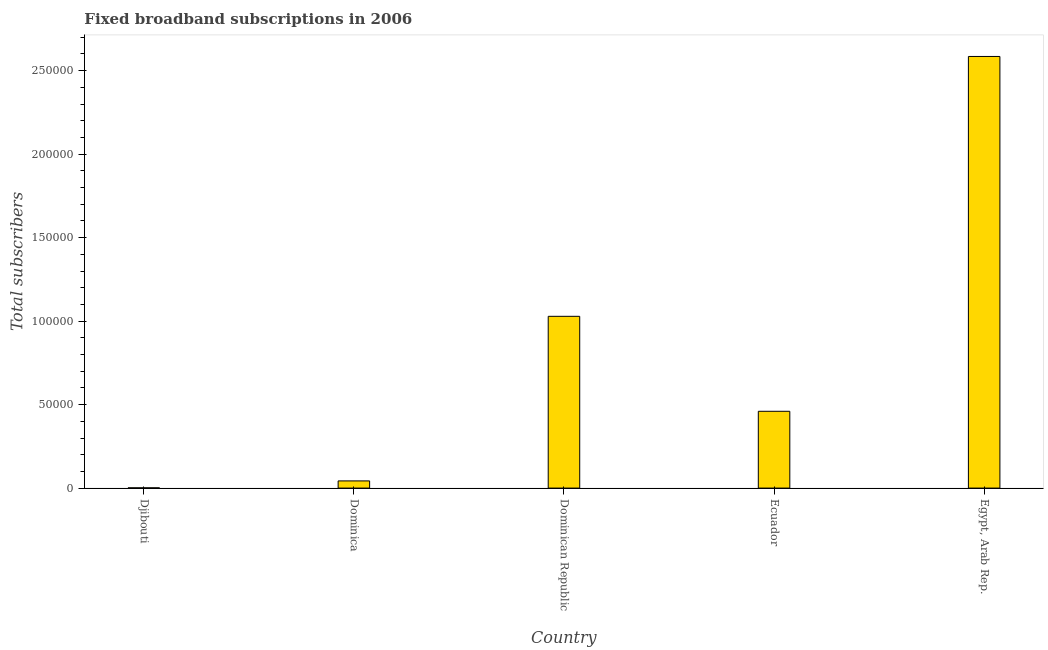What is the title of the graph?
Your answer should be very brief. Fixed broadband subscriptions in 2006. What is the label or title of the X-axis?
Give a very brief answer. Country. What is the label or title of the Y-axis?
Offer a terse response. Total subscribers. What is the total number of fixed broadband subscriptions in Ecuador?
Provide a succinct answer. 4.60e+04. Across all countries, what is the maximum total number of fixed broadband subscriptions?
Your answer should be compact. 2.59e+05. Across all countries, what is the minimum total number of fixed broadband subscriptions?
Ensure brevity in your answer.  152. In which country was the total number of fixed broadband subscriptions maximum?
Give a very brief answer. Egypt, Arab Rep. In which country was the total number of fixed broadband subscriptions minimum?
Make the answer very short. Djibouti. What is the sum of the total number of fixed broadband subscriptions?
Keep it short and to the point. 4.12e+05. What is the difference between the total number of fixed broadband subscriptions in Djibouti and Dominica?
Your response must be concise. -4148. What is the average total number of fixed broadband subscriptions per country?
Your answer should be compact. 8.24e+04. What is the median total number of fixed broadband subscriptions?
Provide a short and direct response. 4.60e+04. In how many countries, is the total number of fixed broadband subscriptions greater than 70000 ?
Keep it short and to the point. 2. What is the ratio of the total number of fixed broadband subscriptions in Dominican Republic to that in Egypt, Arab Rep.?
Keep it short and to the point. 0.4. Is the difference between the total number of fixed broadband subscriptions in Djibouti and Ecuador greater than the difference between any two countries?
Offer a very short reply. No. What is the difference between the highest and the second highest total number of fixed broadband subscriptions?
Keep it short and to the point. 1.56e+05. Is the sum of the total number of fixed broadband subscriptions in Dominican Republic and Egypt, Arab Rep. greater than the maximum total number of fixed broadband subscriptions across all countries?
Provide a succinct answer. Yes. What is the difference between the highest and the lowest total number of fixed broadband subscriptions?
Keep it short and to the point. 2.58e+05. In how many countries, is the total number of fixed broadband subscriptions greater than the average total number of fixed broadband subscriptions taken over all countries?
Your answer should be very brief. 2. How many bars are there?
Your answer should be very brief. 5. How many countries are there in the graph?
Give a very brief answer. 5. What is the Total subscribers of Djibouti?
Provide a short and direct response. 152. What is the Total subscribers in Dominica?
Your response must be concise. 4300. What is the Total subscribers in Dominican Republic?
Keep it short and to the point. 1.03e+05. What is the Total subscribers in Ecuador?
Keep it short and to the point. 4.60e+04. What is the Total subscribers in Egypt, Arab Rep.?
Provide a succinct answer. 2.59e+05. What is the difference between the Total subscribers in Djibouti and Dominica?
Your answer should be very brief. -4148. What is the difference between the Total subscribers in Djibouti and Dominican Republic?
Your answer should be very brief. -1.03e+05. What is the difference between the Total subscribers in Djibouti and Ecuador?
Offer a very short reply. -4.58e+04. What is the difference between the Total subscribers in Djibouti and Egypt, Arab Rep.?
Offer a terse response. -2.58e+05. What is the difference between the Total subscribers in Dominica and Dominican Republic?
Give a very brief answer. -9.86e+04. What is the difference between the Total subscribers in Dominica and Ecuador?
Ensure brevity in your answer.  -4.17e+04. What is the difference between the Total subscribers in Dominica and Egypt, Arab Rep.?
Provide a short and direct response. -2.54e+05. What is the difference between the Total subscribers in Dominican Republic and Ecuador?
Offer a very short reply. 5.69e+04. What is the difference between the Total subscribers in Dominican Republic and Egypt, Arab Rep.?
Offer a very short reply. -1.56e+05. What is the difference between the Total subscribers in Ecuador and Egypt, Arab Rep.?
Ensure brevity in your answer.  -2.13e+05. What is the ratio of the Total subscribers in Djibouti to that in Dominica?
Give a very brief answer. 0.04. What is the ratio of the Total subscribers in Djibouti to that in Ecuador?
Offer a terse response. 0. What is the ratio of the Total subscribers in Djibouti to that in Egypt, Arab Rep.?
Ensure brevity in your answer.  0. What is the ratio of the Total subscribers in Dominica to that in Dominican Republic?
Your answer should be very brief. 0.04. What is the ratio of the Total subscribers in Dominica to that in Ecuador?
Keep it short and to the point. 0.09. What is the ratio of the Total subscribers in Dominica to that in Egypt, Arab Rep.?
Your response must be concise. 0.02. What is the ratio of the Total subscribers in Dominican Republic to that in Ecuador?
Give a very brief answer. 2.24. What is the ratio of the Total subscribers in Dominican Republic to that in Egypt, Arab Rep.?
Provide a succinct answer. 0.4. What is the ratio of the Total subscribers in Ecuador to that in Egypt, Arab Rep.?
Keep it short and to the point. 0.18. 